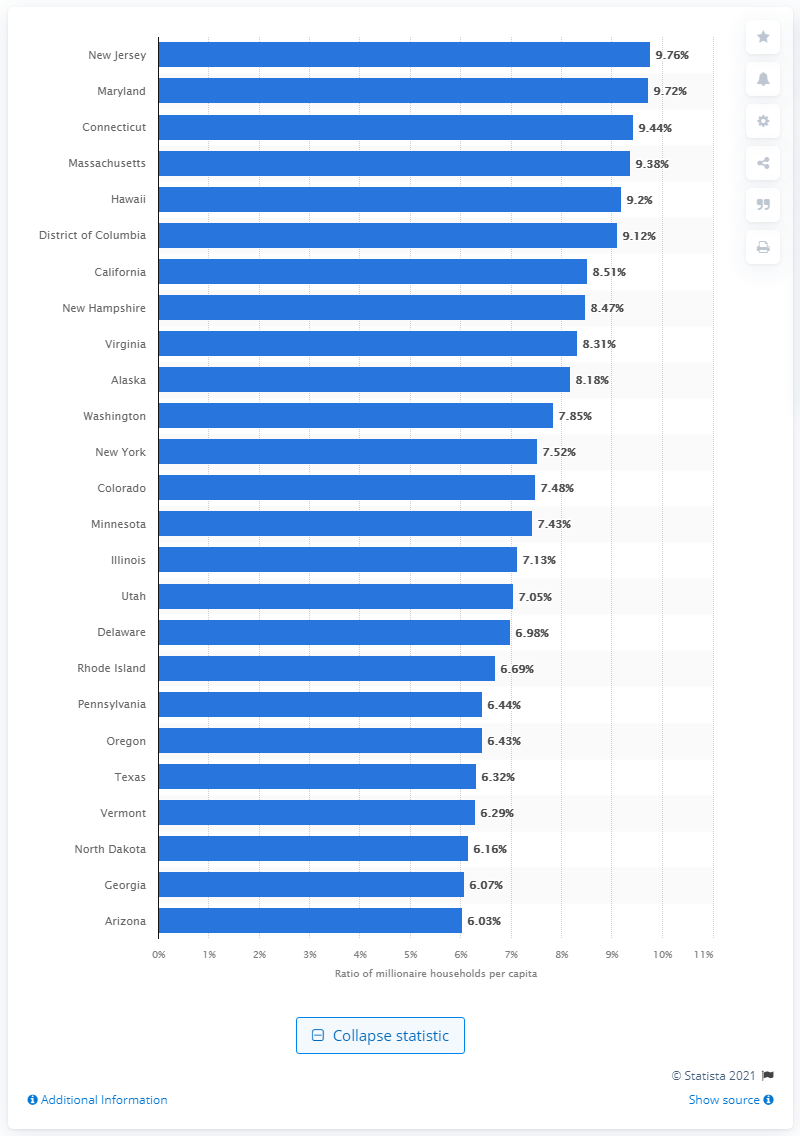Indicate a few pertinent items in this graphic. In 2020, New Jersey had the highest ratio of millionaire households per capita among all states in the country. 